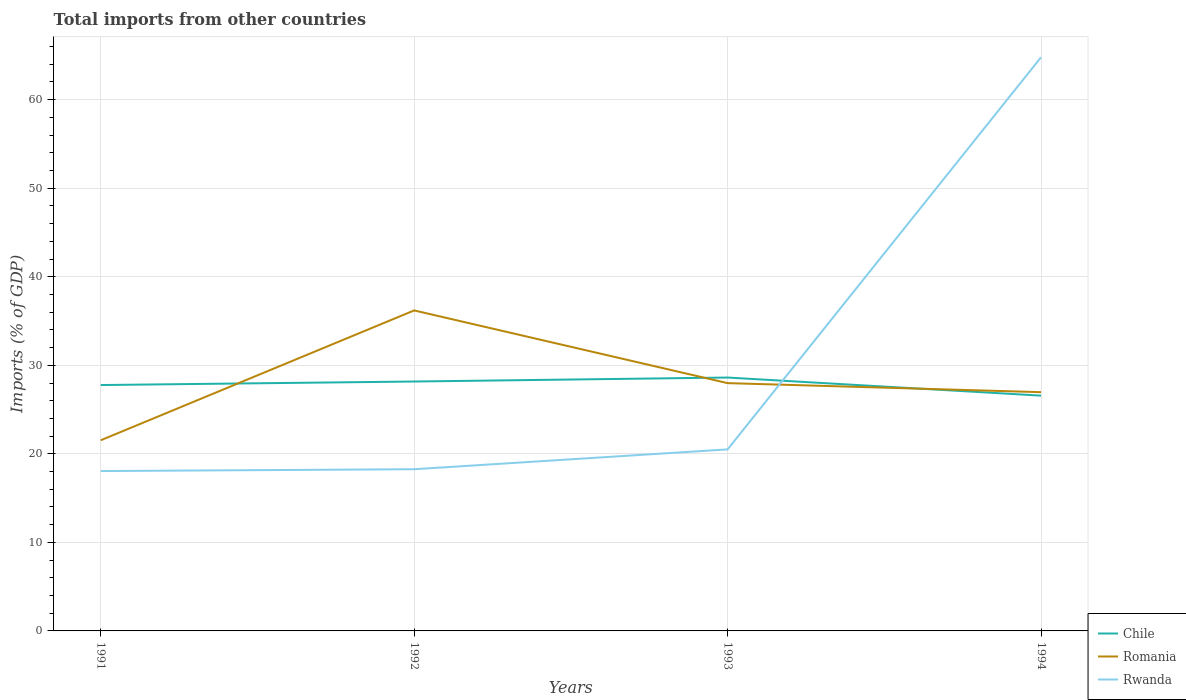Does the line corresponding to Chile intersect with the line corresponding to Rwanda?
Your answer should be very brief. Yes. Across all years, what is the maximum total imports in Rwanda?
Your answer should be compact. 18.06. In which year was the total imports in Romania maximum?
Provide a succinct answer. 1991. What is the total total imports in Romania in the graph?
Your response must be concise. 1.02. What is the difference between the highest and the second highest total imports in Rwanda?
Your response must be concise. 46.74. What is the difference between the highest and the lowest total imports in Romania?
Keep it short and to the point. 1. Is the total imports in Chile strictly greater than the total imports in Romania over the years?
Ensure brevity in your answer.  No. How many years are there in the graph?
Give a very brief answer. 4. Are the values on the major ticks of Y-axis written in scientific E-notation?
Offer a very short reply. No. Does the graph contain grids?
Keep it short and to the point. Yes. Where does the legend appear in the graph?
Your response must be concise. Bottom right. What is the title of the graph?
Your answer should be very brief. Total imports from other countries. Does "Burundi" appear as one of the legend labels in the graph?
Give a very brief answer. No. What is the label or title of the X-axis?
Offer a terse response. Years. What is the label or title of the Y-axis?
Your response must be concise. Imports (% of GDP). What is the Imports (% of GDP) in Chile in 1991?
Your answer should be compact. 27.77. What is the Imports (% of GDP) of Romania in 1991?
Provide a short and direct response. 21.53. What is the Imports (% of GDP) of Rwanda in 1991?
Provide a succinct answer. 18.06. What is the Imports (% of GDP) in Chile in 1992?
Provide a succinct answer. 28.17. What is the Imports (% of GDP) of Romania in 1992?
Ensure brevity in your answer.  36.2. What is the Imports (% of GDP) in Rwanda in 1992?
Offer a very short reply. 18.26. What is the Imports (% of GDP) in Chile in 1993?
Make the answer very short. 28.62. What is the Imports (% of GDP) of Romania in 1993?
Ensure brevity in your answer.  27.99. What is the Imports (% of GDP) in Rwanda in 1993?
Provide a short and direct response. 20.5. What is the Imports (% of GDP) of Chile in 1994?
Provide a succinct answer. 26.57. What is the Imports (% of GDP) of Romania in 1994?
Offer a very short reply. 26.97. What is the Imports (% of GDP) in Rwanda in 1994?
Provide a short and direct response. 64.79. Across all years, what is the maximum Imports (% of GDP) in Chile?
Provide a succinct answer. 28.62. Across all years, what is the maximum Imports (% of GDP) in Romania?
Offer a terse response. 36.2. Across all years, what is the maximum Imports (% of GDP) of Rwanda?
Provide a succinct answer. 64.79. Across all years, what is the minimum Imports (% of GDP) in Chile?
Keep it short and to the point. 26.57. Across all years, what is the minimum Imports (% of GDP) in Romania?
Ensure brevity in your answer.  21.53. Across all years, what is the minimum Imports (% of GDP) of Rwanda?
Keep it short and to the point. 18.06. What is the total Imports (% of GDP) of Chile in the graph?
Offer a terse response. 111.13. What is the total Imports (% of GDP) of Romania in the graph?
Your answer should be very brief. 112.69. What is the total Imports (% of GDP) of Rwanda in the graph?
Your response must be concise. 121.62. What is the difference between the Imports (% of GDP) in Chile in 1991 and that in 1992?
Offer a very short reply. -0.4. What is the difference between the Imports (% of GDP) of Romania in 1991 and that in 1992?
Provide a short and direct response. -14.66. What is the difference between the Imports (% of GDP) in Rwanda in 1991 and that in 1992?
Make the answer very short. -0.21. What is the difference between the Imports (% of GDP) of Chile in 1991 and that in 1993?
Provide a short and direct response. -0.85. What is the difference between the Imports (% of GDP) of Romania in 1991 and that in 1993?
Keep it short and to the point. -6.45. What is the difference between the Imports (% of GDP) in Rwanda in 1991 and that in 1993?
Provide a short and direct response. -2.45. What is the difference between the Imports (% of GDP) in Chile in 1991 and that in 1994?
Give a very brief answer. 1.2. What is the difference between the Imports (% of GDP) in Romania in 1991 and that in 1994?
Offer a terse response. -5.43. What is the difference between the Imports (% of GDP) in Rwanda in 1991 and that in 1994?
Provide a succinct answer. -46.74. What is the difference between the Imports (% of GDP) in Chile in 1992 and that in 1993?
Provide a succinct answer. -0.45. What is the difference between the Imports (% of GDP) of Romania in 1992 and that in 1993?
Offer a very short reply. 8.21. What is the difference between the Imports (% of GDP) in Rwanda in 1992 and that in 1993?
Keep it short and to the point. -2.24. What is the difference between the Imports (% of GDP) in Chile in 1992 and that in 1994?
Keep it short and to the point. 1.59. What is the difference between the Imports (% of GDP) of Romania in 1992 and that in 1994?
Your answer should be very brief. 9.23. What is the difference between the Imports (% of GDP) of Rwanda in 1992 and that in 1994?
Your response must be concise. -46.53. What is the difference between the Imports (% of GDP) of Chile in 1993 and that in 1994?
Your answer should be very brief. 2.04. What is the difference between the Imports (% of GDP) in Romania in 1993 and that in 1994?
Your response must be concise. 1.02. What is the difference between the Imports (% of GDP) in Rwanda in 1993 and that in 1994?
Ensure brevity in your answer.  -44.29. What is the difference between the Imports (% of GDP) of Chile in 1991 and the Imports (% of GDP) of Romania in 1992?
Keep it short and to the point. -8.43. What is the difference between the Imports (% of GDP) of Chile in 1991 and the Imports (% of GDP) of Rwanda in 1992?
Provide a short and direct response. 9.51. What is the difference between the Imports (% of GDP) in Romania in 1991 and the Imports (% of GDP) in Rwanda in 1992?
Your answer should be compact. 3.27. What is the difference between the Imports (% of GDP) of Chile in 1991 and the Imports (% of GDP) of Romania in 1993?
Your answer should be compact. -0.22. What is the difference between the Imports (% of GDP) of Chile in 1991 and the Imports (% of GDP) of Rwanda in 1993?
Offer a very short reply. 7.27. What is the difference between the Imports (% of GDP) of Romania in 1991 and the Imports (% of GDP) of Rwanda in 1993?
Provide a short and direct response. 1.03. What is the difference between the Imports (% of GDP) of Chile in 1991 and the Imports (% of GDP) of Romania in 1994?
Provide a succinct answer. 0.8. What is the difference between the Imports (% of GDP) in Chile in 1991 and the Imports (% of GDP) in Rwanda in 1994?
Provide a succinct answer. -37.02. What is the difference between the Imports (% of GDP) of Romania in 1991 and the Imports (% of GDP) of Rwanda in 1994?
Ensure brevity in your answer.  -43.26. What is the difference between the Imports (% of GDP) of Chile in 1992 and the Imports (% of GDP) of Romania in 1993?
Your response must be concise. 0.18. What is the difference between the Imports (% of GDP) in Chile in 1992 and the Imports (% of GDP) in Rwanda in 1993?
Give a very brief answer. 7.67. What is the difference between the Imports (% of GDP) in Romania in 1992 and the Imports (% of GDP) in Rwanda in 1993?
Offer a terse response. 15.7. What is the difference between the Imports (% of GDP) of Chile in 1992 and the Imports (% of GDP) of Romania in 1994?
Provide a short and direct response. 1.2. What is the difference between the Imports (% of GDP) of Chile in 1992 and the Imports (% of GDP) of Rwanda in 1994?
Your answer should be compact. -36.62. What is the difference between the Imports (% of GDP) of Romania in 1992 and the Imports (% of GDP) of Rwanda in 1994?
Offer a very short reply. -28.59. What is the difference between the Imports (% of GDP) of Chile in 1993 and the Imports (% of GDP) of Romania in 1994?
Your answer should be compact. 1.65. What is the difference between the Imports (% of GDP) of Chile in 1993 and the Imports (% of GDP) of Rwanda in 1994?
Your answer should be very brief. -36.17. What is the difference between the Imports (% of GDP) of Romania in 1993 and the Imports (% of GDP) of Rwanda in 1994?
Ensure brevity in your answer.  -36.81. What is the average Imports (% of GDP) of Chile per year?
Provide a short and direct response. 27.78. What is the average Imports (% of GDP) in Romania per year?
Your answer should be compact. 28.17. What is the average Imports (% of GDP) of Rwanda per year?
Make the answer very short. 30.4. In the year 1991, what is the difference between the Imports (% of GDP) in Chile and Imports (% of GDP) in Romania?
Provide a short and direct response. 6.24. In the year 1991, what is the difference between the Imports (% of GDP) in Chile and Imports (% of GDP) in Rwanda?
Ensure brevity in your answer.  9.71. In the year 1991, what is the difference between the Imports (% of GDP) of Romania and Imports (% of GDP) of Rwanda?
Keep it short and to the point. 3.48. In the year 1992, what is the difference between the Imports (% of GDP) of Chile and Imports (% of GDP) of Romania?
Your answer should be very brief. -8.03. In the year 1992, what is the difference between the Imports (% of GDP) in Chile and Imports (% of GDP) in Rwanda?
Your answer should be compact. 9.91. In the year 1992, what is the difference between the Imports (% of GDP) in Romania and Imports (% of GDP) in Rwanda?
Provide a succinct answer. 17.94. In the year 1993, what is the difference between the Imports (% of GDP) in Chile and Imports (% of GDP) in Romania?
Make the answer very short. 0.63. In the year 1993, what is the difference between the Imports (% of GDP) in Chile and Imports (% of GDP) in Rwanda?
Ensure brevity in your answer.  8.12. In the year 1993, what is the difference between the Imports (% of GDP) in Romania and Imports (% of GDP) in Rwanda?
Your answer should be compact. 7.48. In the year 1994, what is the difference between the Imports (% of GDP) of Chile and Imports (% of GDP) of Romania?
Provide a succinct answer. -0.39. In the year 1994, what is the difference between the Imports (% of GDP) in Chile and Imports (% of GDP) in Rwanda?
Offer a very short reply. -38.22. In the year 1994, what is the difference between the Imports (% of GDP) in Romania and Imports (% of GDP) in Rwanda?
Make the answer very short. -37.83. What is the ratio of the Imports (% of GDP) in Chile in 1991 to that in 1992?
Provide a short and direct response. 0.99. What is the ratio of the Imports (% of GDP) of Romania in 1991 to that in 1992?
Offer a very short reply. 0.59. What is the ratio of the Imports (% of GDP) of Rwanda in 1991 to that in 1992?
Offer a very short reply. 0.99. What is the ratio of the Imports (% of GDP) of Chile in 1991 to that in 1993?
Give a very brief answer. 0.97. What is the ratio of the Imports (% of GDP) in Romania in 1991 to that in 1993?
Your answer should be very brief. 0.77. What is the ratio of the Imports (% of GDP) in Rwanda in 1991 to that in 1993?
Your answer should be compact. 0.88. What is the ratio of the Imports (% of GDP) in Chile in 1991 to that in 1994?
Provide a succinct answer. 1.04. What is the ratio of the Imports (% of GDP) in Romania in 1991 to that in 1994?
Make the answer very short. 0.8. What is the ratio of the Imports (% of GDP) in Rwanda in 1991 to that in 1994?
Provide a succinct answer. 0.28. What is the ratio of the Imports (% of GDP) in Chile in 1992 to that in 1993?
Provide a short and direct response. 0.98. What is the ratio of the Imports (% of GDP) of Romania in 1992 to that in 1993?
Your answer should be very brief. 1.29. What is the ratio of the Imports (% of GDP) in Rwanda in 1992 to that in 1993?
Your answer should be very brief. 0.89. What is the ratio of the Imports (% of GDP) of Chile in 1992 to that in 1994?
Offer a very short reply. 1.06. What is the ratio of the Imports (% of GDP) in Romania in 1992 to that in 1994?
Offer a terse response. 1.34. What is the ratio of the Imports (% of GDP) in Rwanda in 1992 to that in 1994?
Your response must be concise. 0.28. What is the ratio of the Imports (% of GDP) in Romania in 1993 to that in 1994?
Provide a short and direct response. 1.04. What is the ratio of the Imports (% of GDP) in Rwanda in 1993 to that in 1994?
Your answer should be compact. 0.32. What is the difference between the highest and the second highest Imports (% of GDP) in Chile?
Your answer should be compact. 0.45. What is the difference between the highest and the second highest Imports (% of GDP) of Romania?
Offer a terse response. 8.21. What is the difference between the highest and the second highest Imports (% of GDP) in Rwanda?
Your answer should be compact. 44.29. What is the difference between the highest and the lowest Imports (% of GDP) in Chile?
Give a very brief answer. 2.04. What is the difference between the highest and the lowest Imports (% of GDP) of Romania?
Provide a succinct answer. 14.66. What is the difference between the highest and the lowest Imports (% of GDP) in Rwanda?
Your answer should be very brief. 46.74. 